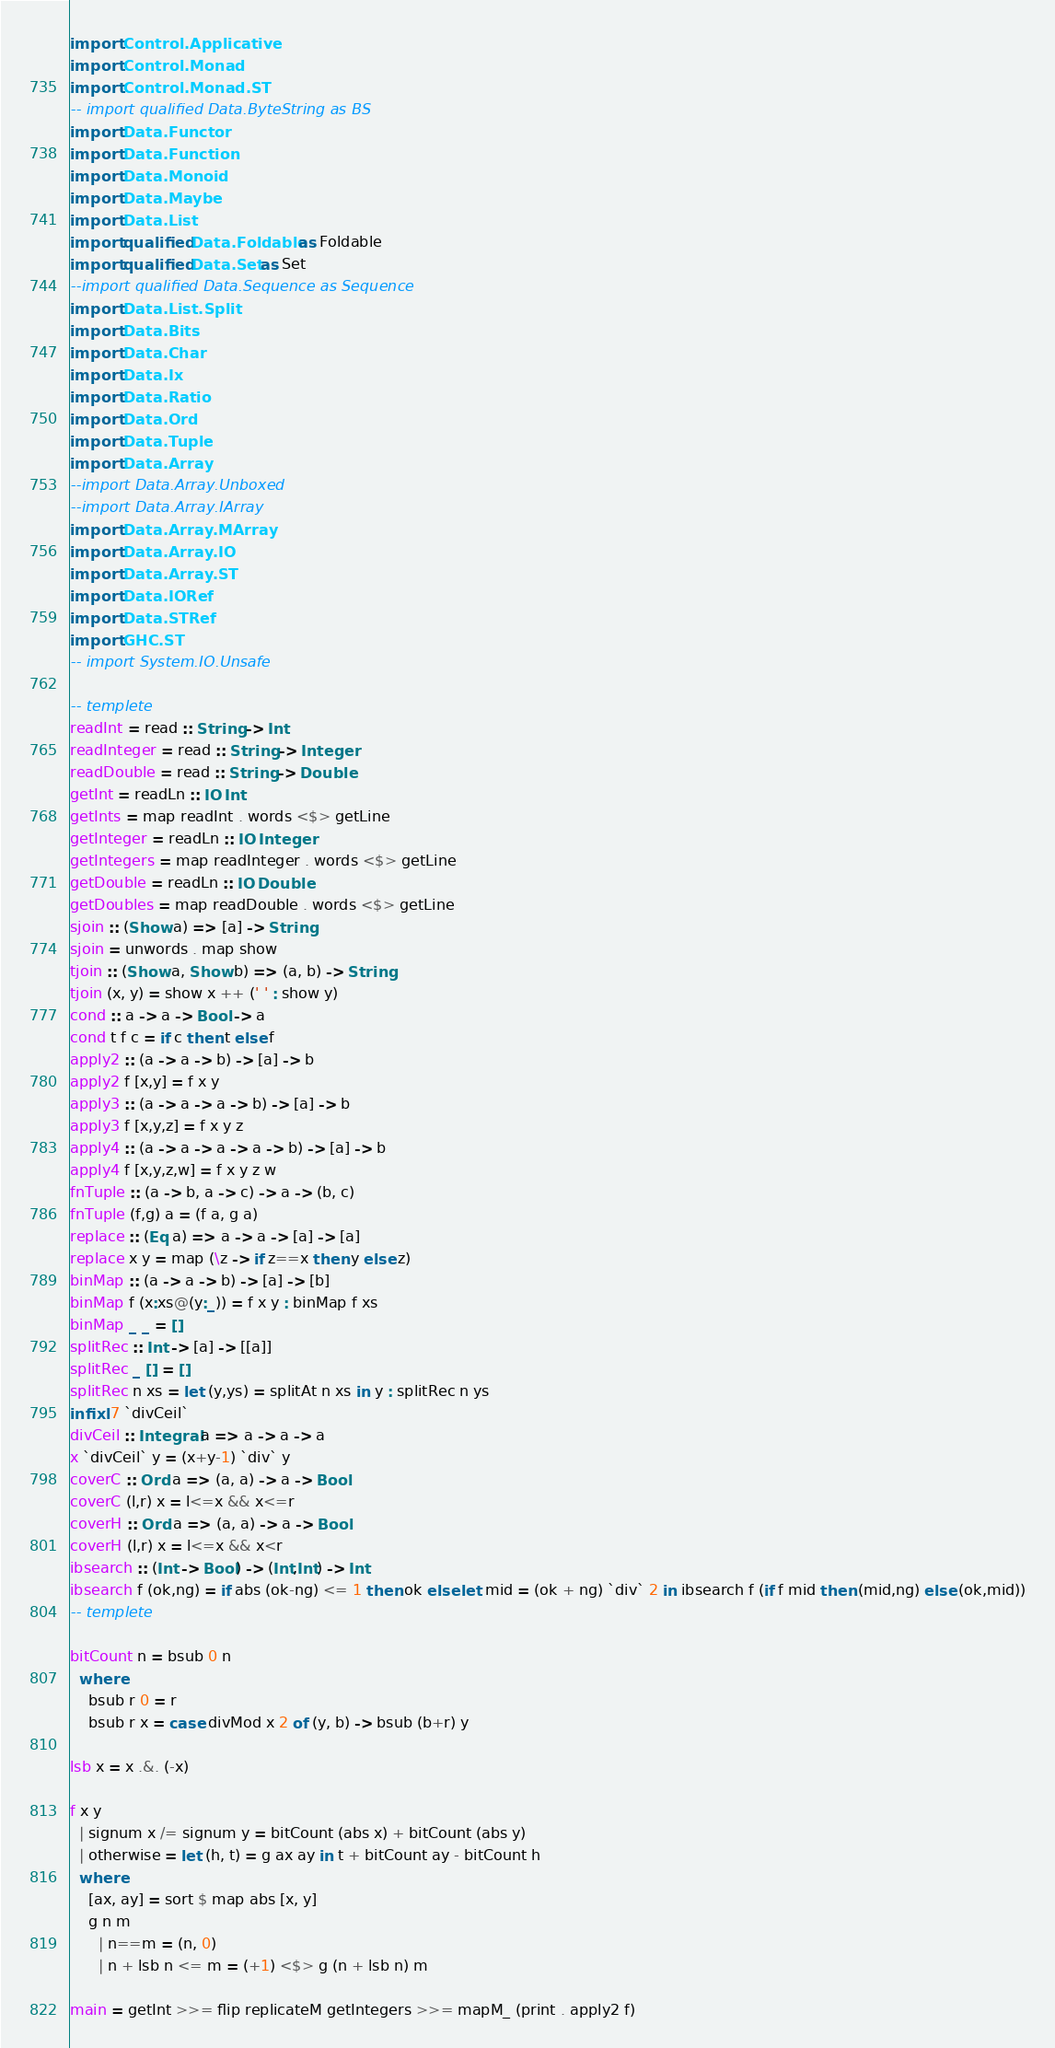Convert code to text. <code><loc_0><loc_0><loc_500><loc_500><_Haskell_>import Control.Applicative
import Control.Monad
import Control.Monad.ST
-- import qualified Data.ByteString as BS
import Data.Functor
import Data.Function
import Data.Monoid
import Data.Maybe
import Data.List
import qualified Data.Foldable as Foldable
import qualified Data.Set as Set
--import qualified Data.Sequence as Sequence
import Data.List.Split
import Data.Bits
import Data.Char
import Data.Ix
import Data.Ratio
import Data.Ord
import Data.Tuple
import Data.Array
--import Data.Array.Unboxed
--import Data.Array.IArray
import Data.Array.MArray
import Data.Array.IO
import Data.Array.ST
import Data.IORef
import Data.STRef
import GHC.ST
-- import System.IO.Unsafe
 
-- templete
readInt = read :: String -> Int
readInteger = read :: String -> Integer
readDouble = read :: String -> Double
getInt = readLn :: IO Int
getInts = map readInt . words <$> getLine
getInteger = readLn :: IO Integer
getIntegers = map readInteger . words <$> getLine
getDouble = readLn :: IO Double
getDoubles = map readDouble . words <$> getLine
sjoin :: (Show a) => [a] -> String
sjoin = unwords . map show
tjoin :: (Show a, Show b) => (a, b) -> String
tjoin (x, y) = show x ++ (' ' : show y)
cond :: a -> a -> Bool -> a
cond t f c = if c then t else f
apply2 :: (a -> a -> b) -> [a] -> b
apply2 f [x,y] = f x y
apply3 :: (a -> a -> a -> b) -> [a] -> b
apply3 f [x,y,z] = f x y z
apply4 :: (a -> a -> a -> a -> b) -> [a] -> b
apply4 f [x,y,z,w] = f x y z w
fnTuple :: (a -> b, a -> c) -> a -> (b, c)
fnTuple (f,g) a = (f a, g a)
replace :: (Eq a) => a -> a -> [a] -> [a]
replace x y = map (\z -> if z==x then y else z)
binMap :: (a -> a -> b) -> [a] -> [b]
binMap f (x:xs@(y:_)) = f x y : binMap f xs
binMap _ _ = []
splitRec :: Int -> [a] -> [[a]]
splitRec _ [] = []
splitRec n xs = let (y,ys) = splitAt n xs in y : splitRec n ys
infixl 7 `divCeil`
divCeil :: Integral a => a -> a -> a
x `divCeil` y = (x+y-1) `div` y
coverC :: Ord a => (a, a) -> a -> Bool
coverC (l,r) x = l<=x && x<=r
coverH :: Ord a => (a, a) -> a -> Bool
coverH (l,r) x = l<=x && x<r
ibsearch :: (Int -> Bool) -> (Int,Int) -> Int
ibsearch f (ok,ng) = if abs (ok-ng) <= 1 then ok else let mid = (ok + ng) `div` 2 in ibsearch f (if f mid then (mid,ng) else (ok,mid))
-- templete

bitCount n = bsub 0 n
  where
    bsub r 0 = r
    bsub r x = case divMod x 2 of (y, b) -> bsub (b+r) y

lsb x = x .&. (-x)

f x y
  | signum x /= signum y = bitCount (abs x) + bitCount (abs y)
  | otherwise = let (h, t) = g ax ay in t + bitCount ay - bitCount h
  where
    [ax, ay] = sort $ map abs [x, y]
    g n m
      | n==m = (n, 0)
      | n + lsb n <= m = (+1) <$> g (n + lsb n) m
 
main = getInt >>= flip replicateM getIntegers >>= mapM_ (print . apply2 f)
</code> 